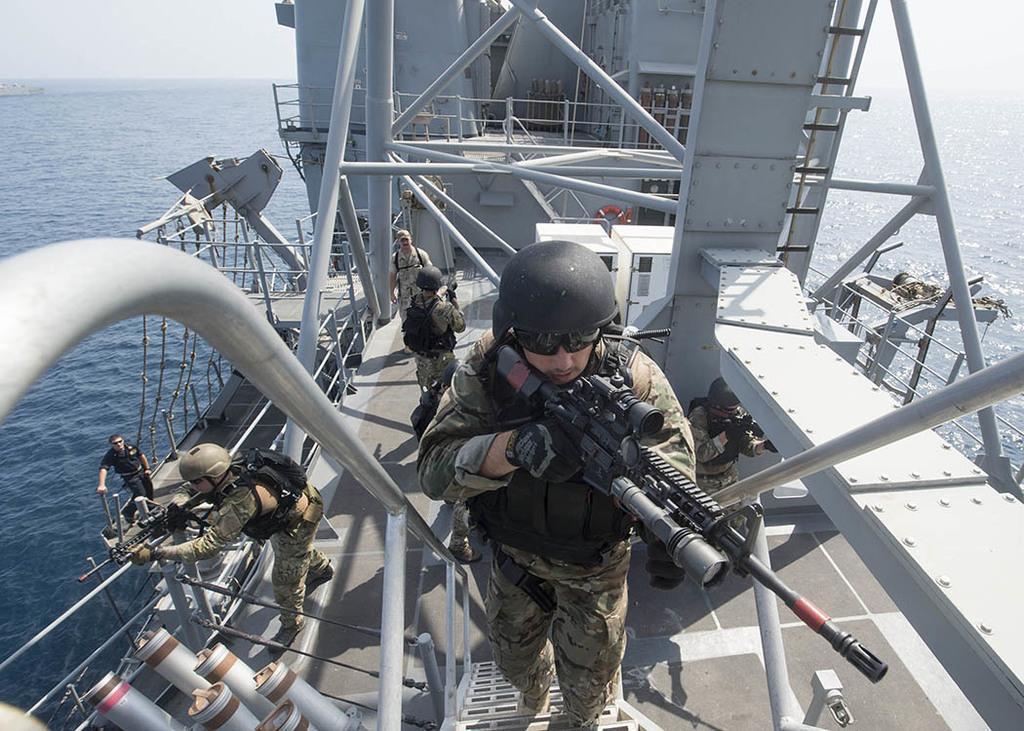Could you give a brief overview of what you see in this image? In this image I can see water and here I can see number of people are standing. I can see all of them are wearing uniforms and few of them are wearing helmets. I can also see few of them are holding guns. 